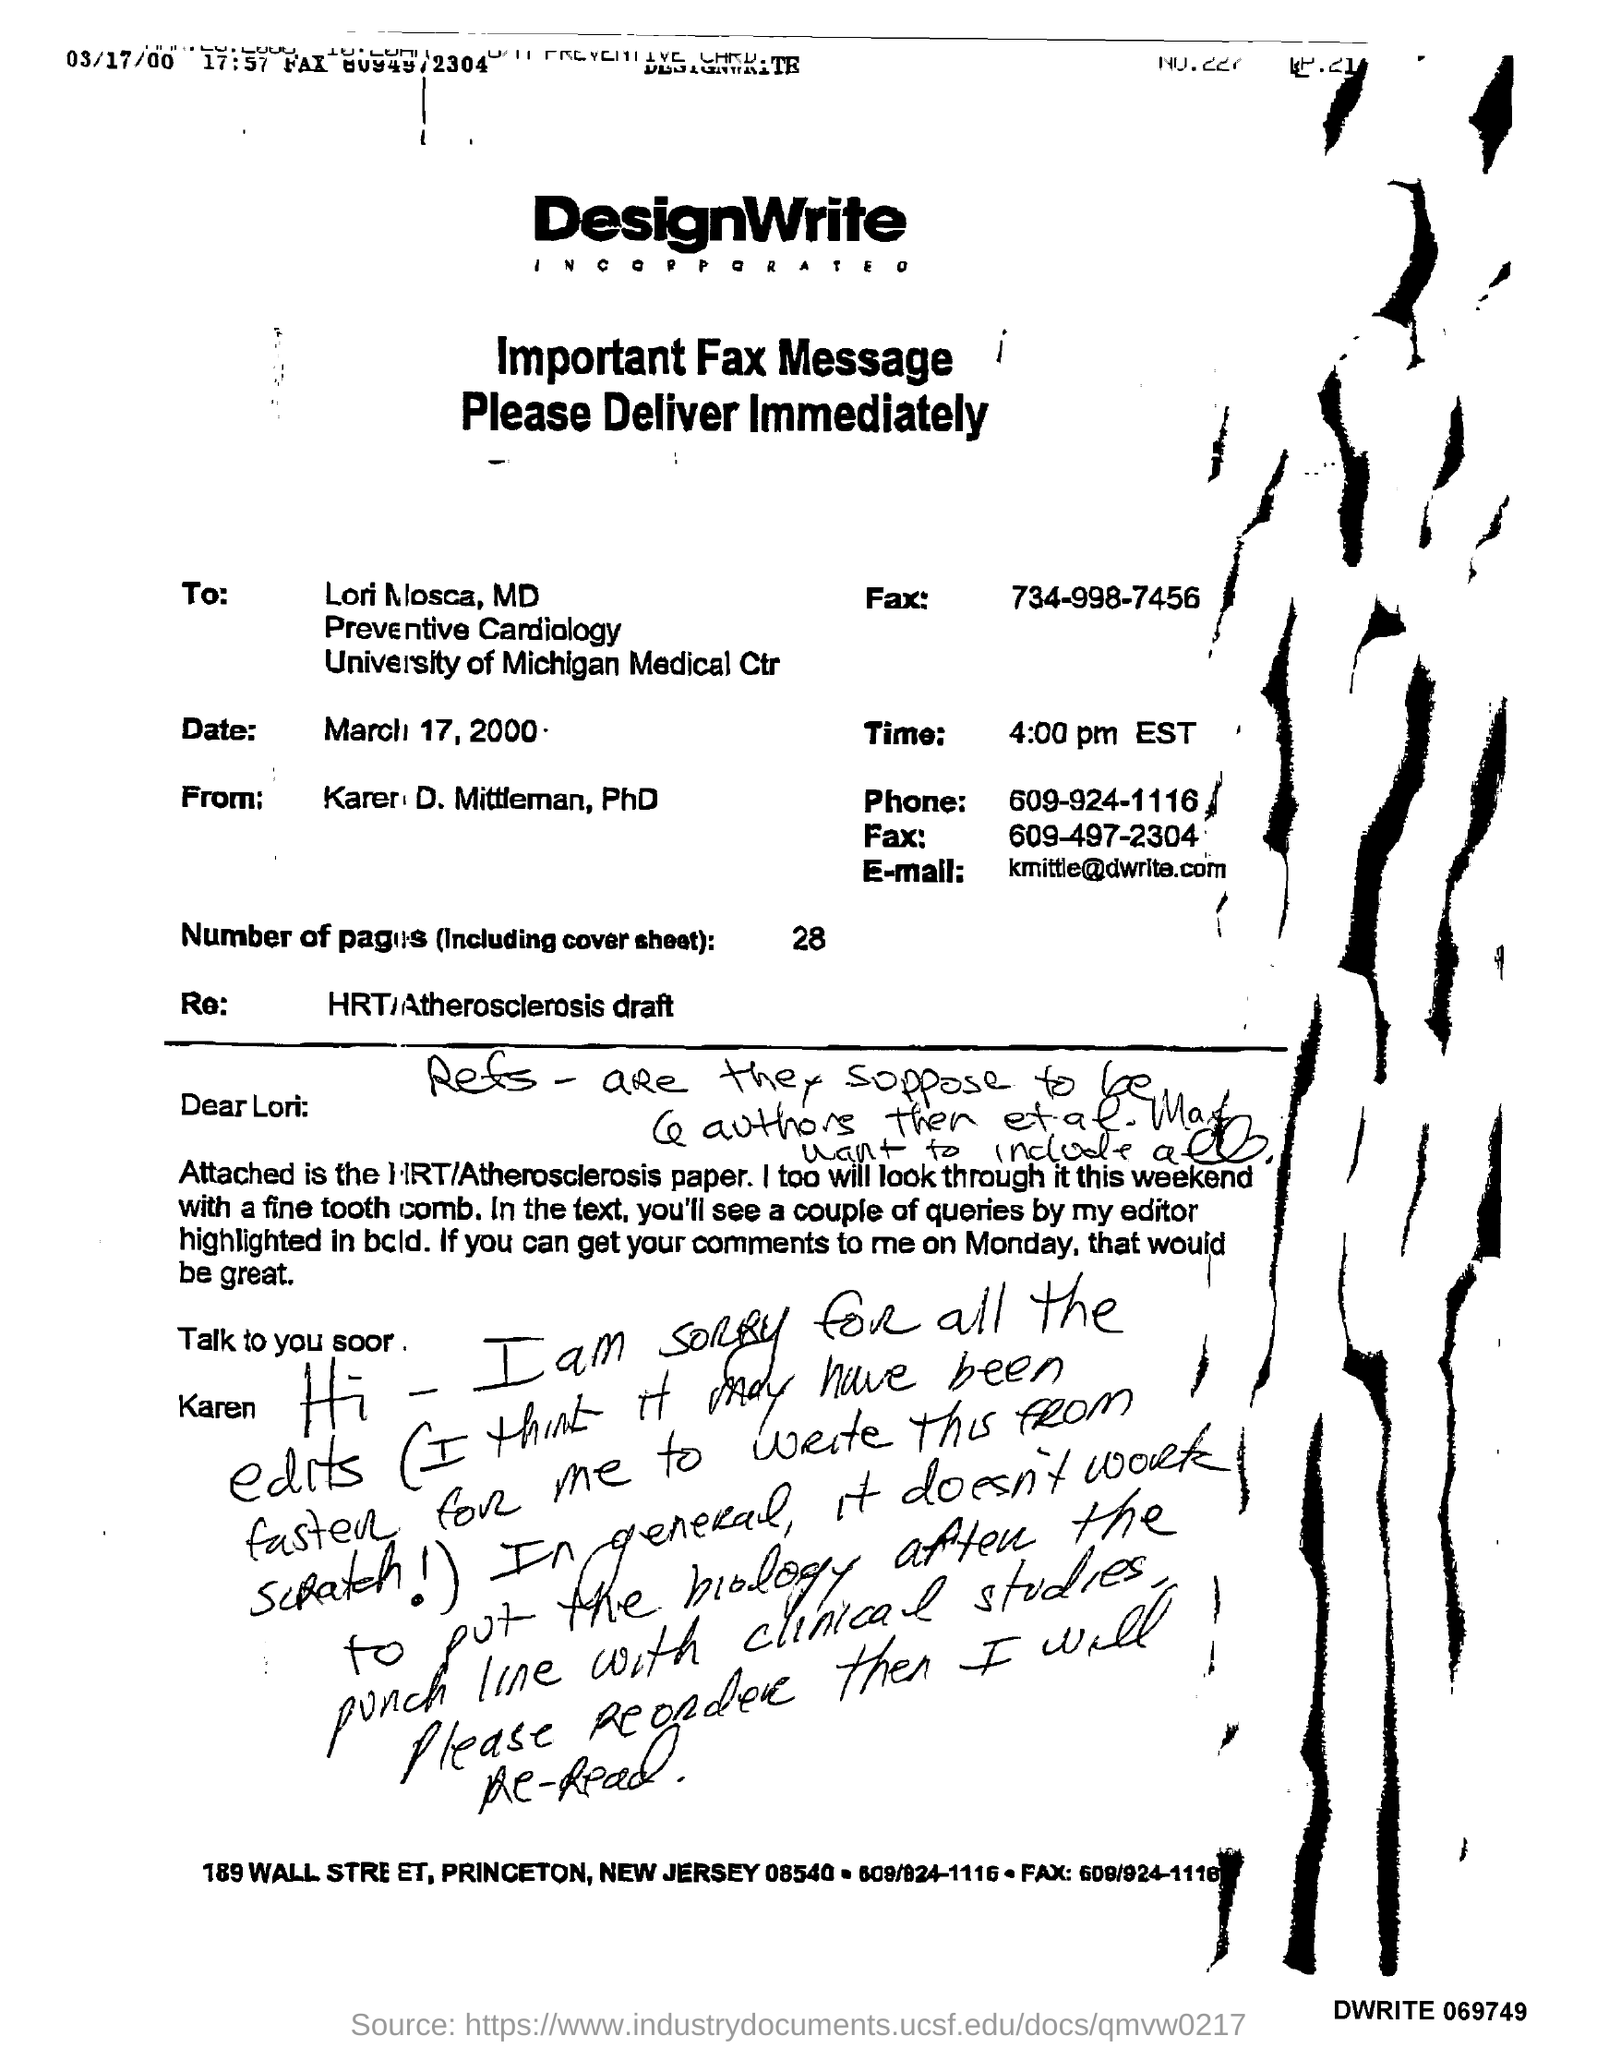Outline some significant characteristics in this image. The email mentioned in the given fax message is [kmittle@dwrite.com](mailto:kmittle@dwrite.com). The date mentioned in the fax message is March 17, 2000. The recipient of the fax message was Lori Mosca, MD. The total number of pages, including the cover sheet, is 28. The phone number provided in the fax message is 609-924-1116. 